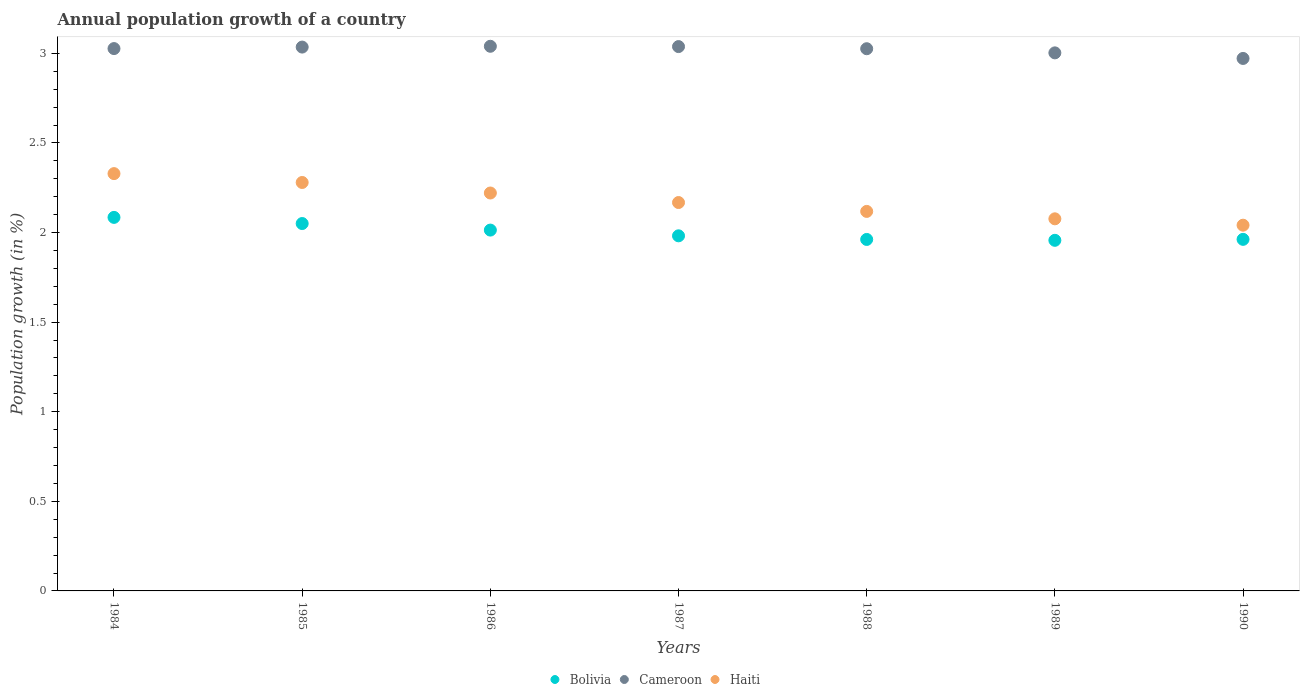How many different coloured dotlines are there?
Ensure brevity in your answer.  3. Is the number of dotlines equal to the number of legend labels?
Make the answer very short. Yes. What is the annual population growth in Bolivia in 1987?
Offer a terse response. 1.98. Across all years, what is the maximum annual population growth in Cameroon?
Keep it short and to the point. 3.04. Across all years, what is the minimum annual population growth in Bolivia?
Keep it short and to the point. 1.96. What is the total annual population growth in Haiti in the graph?
Provide a succinct answer. 15.23. What is the difference between the annual population growth in Bolivia in 1986 and that in 1989?
Make the answer very short. 0.06. What is the difference between the annual population growth in Cameroon in 1984 and the annual population growth in Bolivia in 1988?
Your answer should be compact. 1.07. What is the average annual population growth in Haiti per year?
Provide a short and direct response. 2.18. In the year 1989, what is the difference between the annual population growth in Haiti and annual population growth in Cameroon?
Provide a succinct answer. -0.93. In how many years, is the annual population growth in Cameroon greater than 2.3 %?
Provide a succinct answer. 7. What is the ratio of the annual population growth in Bolivia in 1985 to that in 1986?
Your response must be concise. 1.02. Is the annual population growth in Cameroon in 1984 less than that in 1987?
Make the answer very short. Yes. Is the difference between the annual population growth in Haiti in 1986 and 1988 greater than the difference between the annual population growth in Cameroon in 1986 and 1988?
Your answer should be very brief. Yes. What is the difference between the highest and the second highest annual population growth in Haiti?
Your response must be concise. 0.05. What is the difference between the highest and the lowest annual population growth in Cameroon?
Give a very brief answer. 0.07. Is it the case that in every year, the sum of the annual population growth in Bolivia and annual population growth in Haiti  is greater than the annual population growth in Cameroon?
Your answer should be compact. Yes. Does the annual population growth in Haiti monotonically increase over the years?
Ensure brevity in your answer.  No. Is the annual population growth in Cameroon strictly greater than the annual population growth in Bolivia over the years?
Keep it short and to the point. Yes. Is the annual population growth in Haiti strictly less than the annual population growth in Cameroon over the years?
Keep it short and to the point. Yes. How many dotlines are there?
Your answer should be compact. 3. How many years are there in the graph?
Your response must be concise. 7. What is the difference between two consecutive major ticks on the Y-axis?
Your answer should be compact. 0.5. Are the values on the major ticks of Y-axis written in scientific E-notation?
Keep it short and to the point. No. Does the graph contain grids?
Your response must be concise. No. Where does the legend appear in the graph?
Give a very brief answer. Bottom center. How many legend labels are there?
Offer a very short reply. 3. What is the title of the graph?
Ensure brevity in your answer.  Annual population growth of a country. Does "Gambia, The" appear as one of the legend labels in the graph?
Your answer should be very brief. No. What is the label or title of the X-axis?
Your answer should be compact. Years. What is the label or title of the Y-axis?
Keep it short and to the point. Population growth (in %). What is the Population growth (in %) of Bolivia in 1984?
Give a very brief answer. 2.08. What is the Population growth (in %) in Cameroon in 1984?
Your answer should be very brief. 3.03. What is the Population growth (in %) in Haiti in 1984?
Offer a terse response. 2.33. What is the Population growth (in %) in Bolivia in 1985?
Keep it short and to the point. 2.05. What is the Population growth (in %) in Cameroon in 1985?
Your response must be concise. 3.03. What is the Population growth (in %) in Haiti in 1985?
Your answer should be very brief. 2.28. What is the Population growth (in %) of Bolivia in 1986?
Provide a short and direct response. 2.01. What is the Population growth (in %) of Cameroon in 1986?
Your response must be concise. 3.04. What is the Population growth (in %) of Haiti in 1986?
Offer a terse response. 2.22. What is the Population growth (in %) of Bolivia in 1987?
Your answer should be compact. 1.98. What is the Population growth (in %) of Cameroon in 1987?
Provide a succinct answer. 3.04. What is the Population growth (in %) of Haiti in 1987?
Make the answer very short. 2.17. What is the Population growth (in %) of Bolivia in 1988?
Your answer should be compact. 1.96. What is the Population growth (in %) of Cameroon in 1988?
Ensure brevity in your answer.  3.03. What is the Population growth (in %) of Haiti in 1988?
Provide a short and direct response. 2.12. What is the Population growth (in %) of Bolivia in 1989?
Provide a succinct answer. 1.96. What is the Population growth (in %) of Cameroon in 1989?
Offer a terse response. 3. What is the Population growth (in %) in Haiti in 1989?
Your answer should be very brief. 2.08. What is the Population growth (in %) in Bolivia in 1990?
Give a very brief answer. 1.96. What is the Population growth (in %) in Cameroon in 1990?
Give a very brief answer. 2.97. What is the Population growth (in %) in Haiti in 1990?
Your answer should be compact. 2.04. Across all years, what is the maximum Population growth (in %) in Bolivia?
Offer a very short reply. 2.08. Across all years, what is the maximum Population growth (in %) in Cameroon?
Keep it short and to the point. 3.04. Across all years, what is the maximum Population growth (in %) of Haiti?
Make the answer very short. 2.33. Across all years, what is the minimum Population growth (in %) of Bolivia?
Offer a terse response. 1.96. Across all years, what is the minimum Population growth (in %) in Cameroon?
Ensure brevity in your answer.  2.97. Across all years, what is the minimum Population growth (in %) in Haiti?
Your response must be concise. 2.04. What is the total Population growth (in %) of Bolivia in the graph?
Offer a terse response. 14.01. What is the total Population growth (in %) in Cameroon in the graph?
Your answer should be compact. 21.14. What is the total Population growth (in %) of Haiti in the graph?
Offer a very short reply. 15.23. What is the difference between the Population growth (in %) in Bolivia in 1984 and that in 1985?
Your response must be concise. 0.03. What is the difference between the Population growth (in %) of Cameroon in 1984 and that in 1985?
Keep it short and to the point. -0.01. What is the difference between the Population growth (in %) in Haiti in 1984 and that in 1985?
Your answer should be very brief. 0.05. What is the difference between the Population growth (in %) in Bolivia in 1984 and that in 1986?
Your answer should be very brief. 0.07. What is the difference between the Population growth (in %) in Cameroon in 1984 and that in 1986?
Provide a succinct answer. -0.01. What is the difference between the Population growth (in %) of Haiti in 1984 and that in 1986?
Your response must be concise. 0.11. What is the difference between the Population growth (in %) in Bolivia in 1984 and that in 1987?
Your answer should be compact. 0.1. What is the difference between the Population growth (in %) in Cameroon in 1984 and that in 1987?
Give a very brief answer. -0.01. What is the difference between the Population growth (in %) of Haiti in 1984 and that in 1987?
Give a very brief answer. 0.16. What is the difference between the Population growth (in %) in Bolivia in 1984 and that in 1988?
Your response must be concise. 0.12. What is the difference between the Population growth (in %) in Cameroon in 1984 and that in 1988?
Keep it short and to the point. 0. What is the difference between the Population growth (in %) of Haiti in 1984 and that in 1988?
Offer a terse response. 0.21. What is the difference between the Population growth (in %) in Bolivia in 1984 and that in 1989?
Provide a succinct answer. 0.13. What is the difference between the Population growth (in %) in Cameroon in 1984 and that in 1989?
Keep it short and to the point. 0.02. What is the difference between the Population growth (in %) of Haiti in 1984 and that in 1989?
Offer a terse response. 0.25. What is the difference between the Population growth (in %) in Bolivia in 1984 and that in 1990?
Provide a succinct answer. 0.12. What is the difference between the Population growth (in %) of Cameroon in 1984 and that in 1990?
Provide a short and direct response. 0.06. What is the difference between the Population growth (in %) in Haiti in 1984 and that in 1990?
Give a very brief answer. 0.29. What is the difference between the Population growth (in %) in Bolivia in 1985 and that in 1986?
Offer a terse response. 0.04. What is the difference between the Population growth (in %) in Cameroon in 1985 and that in 1986?
Your answer should be compact. -0. What is the difference between the Population growth (in %) of Haiti in 1985 and that in 1986?
Your answer should be compact. 0.06. What is the difference between the Population growth (in %) of Bolivia in 1985 and that in 1987?
Keep it short and to the point. 0.07. What is the difference between the Population growth (in %) in Cameroon in 1985 and that in 1987?
Your answer should be very brief. -0. What is the difference between the Population growth (in %) in Haiti in 1985 and that in 1987?
Your response must be concise. 0.11. What is the difference between the Population growth (in %) of Bolivia in 1985 and that in 1988?
Ensure brevity in your answer.  0.09. What is the difference between the Population growth (in %) of Cameroon in 1985 and that in 1988?
Provide a short and direct response. 0.01. What is the difference between the Population growth (in %) in Haiti in 1985 and that in 1988?
Your answer should be compact. 0.16. What is the difference between the Population growth (in %) of Bolivia in 1985 and that in 1989?
Your answer should be compact. 0.09. What is the difference between the Population growth (in %) of Cameroon in 1985 and that in 1989?
Your answer should be very brief. 0.03. What is the difference between the Population growth (in %) in Haiti in 1985 and that in 1989?
Provide a short and direct response. 0.2. What is the difference between the Population growth (in %) in Bolivia in 1985 and that in 1990?
Provide a succinct answer. 0.09. What is the difference between the Population growth (in %) of Cameroon in 1985 and that in 1990?
Ensure brevity in your answer.  0.06. What is the difference between the Population growth (in %) of Haiti in 1985 and that in 1990?
Provide a succinct answer. 0.24. What is the difference between the Population growth (in %) of Bolivia in 1986 and that in 1987?
Your response must be concise. 0.03. What is the difference between the Population growth (in %) of Cameroon in 1986 and that in 1987?
Provide a succinct answer. 0. What is the difference between the Population growth (in %) in Haiti in 1986 and that in 1987?
Keep it short and to the point. 0.05. What is the difference between the Population growth (in %) in Bolivia in 1986 and that in 1988?
Keep it short and to the point. 0.05. What is the difference between the Population growth (in %) of Cameroon in 1986 and that in 1988?
Provide a short and direct response. 0.01. What is the difference between the Population growth (in %) in Haiti in 1986 and that in 1988?
Make the answer very short. 0.1. What is the difference between the Population growth (in %) in Bolivia in 1986 and that in 1989?
Offer a very short reply. 0.06. What is the difference between the Population growth (in %) of Cameroon in 1986 and that in 1989?
Give a very brief answer. 0.04. What is the difference between the Population growth (in %) of Haiti in 1986 and that in 1989?
Offer a very short reply. 0.14. What is the difference between the Population growth (in %) of Bolivia in 1986 and that in 1990?
Provide a short and direct response. 0.05. What is the difference between the Population growth (in %) of Cameroon in 1986 and that in 1990?
Keep it short and to the point. 0.07. What is the difference between the Population growth (in %) in Haiti in 1986 and that in 1990?
Make the answer very short. 0.18. What is the difference between the Population growth (in %) in Bolivia in 1987 and that in 1988?
Make the answer very short. 0.02. What is the difference between the Population growth (in %) in Cameroon in 1987 and that in 1988?
Your response must be concise. 0.01. What is the difference between the Population growth (in %) in Haiti in 1987 and that in 1988?
Give a very brief answer. 0.05. What is the difference between the Population growth (in %) of Bolivia in 1987 and that in 1989?
Your answer should be compact. 0.03. What is the difference between the Population growth (in %) of Cameroon in 1987 and that in 1989?
Keep it short and to the point. 0.04. What is the difference between the Population growth (in %) of Haiti in 1987 and that in 1989?
Your response must be concise. 0.09. What is the difference between the Population growth (in %) in Bolivia in 1987 and that in 1990?
Offer a very short reply. 0.02. What is the difference between the Population growth (in %) in Cameroon in 1987 and that in 1990?
Make the answer very short. 0.07. What is the difference between the Population growth (in %) of Haiti in 1987 and that in 1990?
Provide a succinct answer. 0.13. What is the difference between the Population growth (in %) in Bolivia in 1988 and that in 1989?
Your response must be concise. 0. What is the difference between the Population growth (in %) of Cameroon in 1988 and that in 1989?
Provide a succinct answer. 0.02. What is the difference between the Population growth (in %) in Haiti in 1988 and that in 1989?
Make the answer very short. 0.04. What is the difference between the Population growth (in %) in Bolivia in 1988 and that in 1990?
Provide a short and direct response. -0. What is the difference between the Population growth (in %) in Cameroon in 1988 and that in 1990?
Keep it short and to the point. 0.05. What is the difference between the Population growth (in %) in Haiti in 1988 and that in 1990?
Your response must be concise. 0.08. What is the difference between the Population growth (in %) in Bolivia in 1989 and that in 1990?
Provide a short and direct response. -0.01. What is the difference between the Population growth (in %) in Cameroon in 1989 and that in 1990?
Make the answer very short. 0.03. What is the difference between the Population growth (in %) of Haiti in 1989 and that in 1990?
Ensure brevity in your answer.  0.04. What is the difference between the Population growth (in %) in Bolivia in 1984 and the Population growth (in %) in Cameroon in 1985?
Offer a terse response. -0.95. What is the difference between the Population growth (in %) in Bolivia in 1984 and the Population growth (in %) in Haiti in 1985?
Offer a very short reply. -0.19. What is the difference between the Population growth (in %) of Cameroon in 1984 and the Population growth (in %) of Haiti in 1985?
Provide a succinct answer. 0.75. What is the difference between the Population growth (in %) in Bolivia in 1984 and the Population growth (in %) in Cameroon in 1986?
Give a very brief answer. -0.95. What is the difference between the Population growth (in %) in Bolivia in 1984 and the Population growth (in %) in Haiti in 1986?
Make the answer very short. -0.14. What is the difference between the Population growth (in %) of Cameroon in 1984 and the Population growth (in %) of Haiti in 1986?
Offer a very short reply. 0.81. What is the difference between the Population growth (in %) in Bolivia in 1984 and the Population growth (in %) in Cameroon in 1987?
Make the answer very short. -0.95. What is the difference between the Population growth (in %) of Bolivia in 1984 and the Population growth (in %) of Haiti in 1987?
Your answer should be very brief. -0.08. What is the difference between the Population growth (in %) in Cameroon in 1984 and the Population growth (in %) in Haiti in 1987?
Keep it short and to the point. 0.86. What is the difference between the Population growth (in %) in Bolivia in 1984 and the Population growth (in %) in Cameroon in 1988?
Offer a terse response. -0.94. What is the difference between the Population growth (in %) of Bolivia in 1984 and the Population growth (in %) of Haiti in 1988?
Offer a very short reply. -0.03. What is the difference between the Population growth (in %) of Cameroon in 1984 and the Population growth (in %) of Haiti in 1988?
Offer a terse response. 0.91. What is the difference between the Population growth (in %) of Bolivia in 1984 and the Population growth (in %) of Cameroon in 1989?
Your answer should be compact. -0.92. What is the difference between the Population growth (in %) of Bolivia in 1984 and the Population growth (in %) of Haiti in 1989?
Offer a very short reply. 0.01. What is the difference between the Population growth (in %) in Cameroon in 1984 and the Population growth (in %) in Haiti in 1989?
Your answer should be very brief. 0.95. What is the difference between the Population growth (in %) in Bolivia in 1984 and the Population growth (in %) in Cameroon in 1990?
Offer a very short reply. -0.89. What is the difference between the Population growth (in %) of Bolivia in 1984 and the Population growth (in %) of Haiti in 1990?
Offer a very short reply. 0.04. What is the difference between the Population growth (in %) of Cameroon in 1984 and the Population growth (in %) of Haiti in 1990?
Ensure brevity in your answer.  0.99. What is the difference between the Population growth (in %) in Bolivia in 1985 and the Population growth (in %) in Cameroon in 1986?
Give a very brief answer. -0.99. What is the difference between the Population growth (in %) in Bolivia in 1985 and the Population growth (in %) in Haiti in 1986?
Ensure brevity in your answer.  -0.17. What is the difference between the Population growth (in %) in Cameroon in 1985 and the Population growth (in %) in Haiti in 1986?
Provide a short and direct response. 0.81. What is the difference between the Population growth (in %) in Bolivia in 1985 and the Population growth (in %) in Cameroon in 1987?
Offer a terse response. -0.99. What is the difference between the Population growth (in %) in Bolivia in 1985 and the Population growth (in %) in Haiti in 1987?
Offer a terse response. -0.12. What is the difference between the Population growth (in %) in Cameroon in 1985 and the Population growth (in %) in Haiti in 1987?
Provide a succinct answer. 0.87. What is the difference between the Population growth (in %) of Bolivia in 1985 and the Population growth (in %) of Cameroon in 1988?
Offer a very short reply. -0.98. What is the difference between the Population growth (in %) of Bolivia in 1985 and the Population growth (in %) of Haiti in 1988?
Provide a succinct answer. -0.07. What is the difference between the Population growth (in %) in Cameroon in 1985 and the Population growth (in %) in Haiti in 1988?
Ensure brevity in your answer.  0.92. What is the difference between the Population growth (in %) of Bolivia in 1985 and the Population growth (in %) of Cameroon in 1989?
Your response must be concise. -0.95. What is the difference between the Population growth (in %) of Bolivia in 1985 and the Population growth (in %) of Haiti in 1989?
Your answer should be compact. -0.03. What is the difference between the Population growth (in %) in Cameroon in 1985 and the Population growth (in %) in Haiti in 1989?
Offer a terse response. 0.96. What is the difference between the Population growth (in %) of Bolivia in 1985 and the Population growth (in %) of Cameroon in 1990?
Make the answer very short. -0.92. What is the difference between the Population growth (in %) of Bolivia in 1985 and the Population growth (in %) of Haiti in 1990?
Ensure brevity in your answer.  0.01. What is the difference between the Population growth (in %) of Cameroon in 1985 and the Population growth (in %) of Haiti in 1990?
Provide a short and direct response. 0.99. What is the difference between the Population growth (in %) of Bolivia in 1986 and the Population growth (in %) of Cameroon in 1987?
Provide a succinct answer. -1.02. What is the difference between the Population growth (in %) of Bolivia in 1986 and the Population growth (in %) of Haiti in 1987?
Keep it short and to the point. -0.15. What is the difference between the Population growth (in %) of Cameroon in 1986 and the Population growth (in %) of Haiti in 1987?
Your response must be concise. 0.87. What is the difference between the Population growth (in %) in Bolivia in 1986 and the Population growth (in %) in Cameroon in 1988?
Ensure brevity in your answer.  -1.01. What is the difference between the Population growth (in %) of Bolivia in 1986 and the Population growth (in %) of Haiti in 1988?
Provide a succinct answer. -0.1. What is the difference between the Population growth (in %) in Cameroon in 1986 and the Population growth (in %) in Haiti in 1988?
Offer a very short reply. 0.92. What is the difference between the Population growth (in %) in Bolivia in 1986 and the Population growth (in %) in Cameroon in 1989?
Your response must be concise. -0.99. What is the difference between the Population growth (in %) in Bolivia in 1986 and the Population growth (in %) in Haiti in 1989?
Offer a very short reply. -0.06. What is the difference between the Population growth (in %) in Cameroon in 1986 and the Population growth (in %) in Haiti in 1989?
Provide a succinct answer. 0.96. What is the difference between the Population growth (in %) of Bolivia in 1986 and the Population growth (in %) of Cameroon in 1990?
Your response must be concise. -0.96. What is the difference between the Population growth (in %) in Bolivia in 1986 and the Population growth (in %) in Haiti in 1990?
Keep it short and to the point. -0.03. What is the difference between the Population growth (in %) of Bolivia in 1987 and the Population growth (in %) of Cameroon in 1988?
Provide a short and direct response. -1.04. What is the difference between the Population growth (in %) of Bolivia in 1987 and the Population growth (in %) of Haiti in 1988?
Your answer should be compact. -0.14. What is the difference between the Population growth (in %) of Cameroon in 1987 and the Population growth (in %) of Haiti in 1988?
Your response must be concise. 0.92. What is the difference between the Population growth (in %) in Bolivia in 1987 and the Population growth (in %) in Cameroon in 1989?
Provide a succinct answer. -1.02. What is the difference between the Population growth (in %) in Bolivia in 1987 and the Population growth (in %) in Haiti in 1989?
Offer a terse response. -0.09. What is the difference between the Population growth (in %) of Cameroon in 1987 and the Population growth (in %) of Haiti in 1989?
Keep it short and to the point. 0.96. What is the difference between the Population growth (in %) in Bolivia in 1987 and the Population growth (in %) in Cameroon in 1990?
Offer a terse response. -0.99. What is the difference between the Population growth (in %) of Bolivia in 1987 and the Population growth (in %) of Haiti in 1990?
Your answer should be very brief. -0.06. What is the difference between the Population growth (in %) of Cameroon in 1987 and the Population growth (in %) of Haiti in 1990?
Give a very brief answer. 1. What is the difference between the Population growth (in %) of Bolivia in 1988 and the Population growth (in %) of Cameroon in 1989?
Provide a short and direct response. -1.04. What is the difference between the Population growth (in %) in Bolivia in 1988 and the Population growth (in %) in Haiti in 1989?
Keep it short and to the point. -0.12. What is the difference between the Population growth (in %) in Cameroon in 1988 and the Population growth (in %) in Haiti in 1989?
Ensure brevity in your answer.  0.95. What is the difference between the Population growth (in %) in Bolivia in 1988 and the Population growth (in %) in Cameroon in 1990?
Offer a very short reply. -1.01. What is the difference between the Population growth (in %) in Bolivia in 1988 and the Population growth (in %) in Haiti in 1990?
Provide a short and direct response. -0.08. What is the difference between the Population growth (in %) in Cameroon in 1988 and the Population growth (in %) in Haiti in 1990?
Provide a short and direct response. 0.98. What is the difference between the Population growth (in %) in Bolivia in 1989 and the Population growth (in %) in Cameroon in 1990?
Give a very brief answer. -1.01. What is the difference between the Population growth (in %) of Bolivia in 1989 and the Population growth (in %) of Haiti in 1990?
Your answer should be compact. -0.08. What is the difference between the Population growth (in %) of Cameroon in 1989 and the Population growth (in %) of Haiti in 1990?
Provide a short and direct response. 0.96. What is the average Population growth (in %) in Bolivia per year?
Keep it short and to the point. 2. What is the average Population growth (in %) in Cameroon per year?
Provide a succinct answer. 3.02. What is the average Population growth (in %) of Haiti per year?
Make the answer very short. 2.18. In the year 1984, what is the difference between the Population growth (in %) in Bolivia and Population growth (in %) in Cameroon?
Give a very brief answer. -0.94. In the year 1984, what is the difference between the Population growth (in %) of Bolivia and Population growth (in %) of Haiti?
Offer a terse response. -0.24. In the year 1984, what is the difference between the Population growth (in %) of Cameroon and Population growth (in %) of Haiti?
Make the answer very short. 0.7. In the year 1985, what is the difference between the Population growth (in %) in Bolivia and Population growth (in %) in Cameroon?
Your answer should be compact. -0.98. In the year 1985, what is the difference between the Population growth (in %) of Bolivia and Population growth (in %) of Haiti?
Give a very brief answer. -0.23. In the year 1985, what is the difference between the Population growth (in %) of Cameroon and Population growth (in %) of Haiti?
Provide a short and direct response. 0.76. In the year 1986, what is the difference between the Population growth (in %) of Bolivia and Population growth (in %) of Cameroon?
Your answer should be compact. -1.03. In the year 1986, what is the difference between the Population growth (in %) of Bolivia and Population growth (in %) of Haiti?
Your answer should be very brief. -0.21. In the year 1986, what is the difference between the Population growth (in %) of Cameroon and Population growth (in %) of Haiti?
Give a very brief answer. 0.82. In the year 1987, what is the difference between the Population growth (in %) of Bolivia and Population growth (in %) of Cameroon?
Provide a succinct answer. -1.06. In the year 1987, what is the difference between the Population growth (in %) of Bolivia and Population growth (in %) of Haiti?
Give a very brief answer. -0.19. In the year 1987, what is the difference between the Population growth (in %) of Cameroon and Population growth (in %) of Haiti?
Your answer should be very brief. 0.87. In the year 1988, what is the difference between the Population growth (in %) in Bolivia and Population growth (in %) in Cameroon?
Keep it short and to the point. -1.06. In the year 1988, what is the difference between the Population growth (in %) in Bolivia and Population growth (in %) in Haiti?
Offer a very short reply. -0.16. In the year 1988, what is the difference between the Population growth (in %) in Cameroon and Population growth (in %) in Haiti?
Give a very brief answer. 0.91. In the year 1989, what is the difference between the Population growth (in %) of Bolivia and Population growth (in %) of Cameroon?
Your answer should be very brief. -1.05. In the year 1989, what is the difference between the Population growth (in %) in Bolivia and Population growth (in %) in Haiti?
Give a very brief answer. -0.12. In the year 1989, what is the difference between the Population growth (in %) of Cameroon and Population growth (in %) of Haiti?
Ensure brevity in your answer.  0.93. In the year 1990, what is the difference between the Population growth (in %) in Bolivia and Population growth (in %) in Cameroon?
Your answer should be compact. -1.01. In the year 1990, what is the difference between the Population growth (in %) in Bolivia and Population growth (in %) in Haiti?
Offer a very short reply. -0.08. In the year 1990, what is the difference between the Population growth (in %) of Cameroon and Population growth (in %) of Haiti?
Your answer should be very brief. 0.93. What is the ratio of the Population growth (in %) of Bolivia in 1984 to that in 1985?
Offer a terse response. 1.02. What is the ratio of the Population growth (in %) in Haiti in 1984 to that in 1985?
Offer a terse response. 1.02. What is the ratio of the Population growth (in %) of Bolivia in 1984 to that in 1986?
Provide a succinct answer. 1.04. What is the ratio of the Population growth (in %) of Haiti in 1984 to that in 1986?
Your answer should be compact. 1.05. What is the ratio of the Population growth (in %) of Bolivia in 1984 to that in 1987?
Make the answer very short. 1.05. What is the ratio of the Population growth (in %) in Haiti in 1984 to that in 1987?
Ensure brevity in your answer.  1.07. What is the ratio of the Population growth (in %) in Bolivia in 1984 to that in 1988?
Your answer should be compact. 1.06. What is the ratio of the Population growth (in %) of Cameroon in 1984 to that in 1988?
Keep it short and to the point. 1. What is the ratio of the Population growth (in %) of Haiti in 1984 to that in 1988?
Give a very brief answer. 1.1. What is the ratio of the Population growth (in %) of Bolivia in 1984 to that in 1989?
Ensure brevity in your answer.  1.07. What is the ratio of the Population growth (in %) in Cameroon in 1984 to that in 1989?
Provide a succinct answer. 1.01. What is the ratio of the Population growth (in %) of Haiti in 1984 to that in 1989?
Your answer should be compact. 1.12. What is the ratio of the Population growth (in %) in Bolivia in 1984 to that in 1990?
Give a very brief answer. 1.06. What is the ratio of the Population growth (in %) in Cameroon in 1984 to that in 1990?
Provide a succinct answer. 1.02. What is the ratio of the Population growth (in %) in Haiti in 1984 to that in 1990?
Ensure brevity in your answer.  1.14. What is the ratio of the Population growth (in %) in Bolivia in 1985 to that in 1986?
Your response must be concise. 1.02. What is the ratio of the Population growth (in %) of Cameroon in 1985 to that in 1986?
Your response must be concise. 1. What is the ratio of the Population growth (in %) of Haiti in 1985 to that in 1986?
Provide a short and direct response. 1.03. What is the ratio of the Population growth (in %) in Bolivia in 1985 to that in 1987?
Make the answer very short. 1.03. What is the ratio of the Population growth (in %) of Haiti in 1985 to that in 1987?
Give a very brief answer. 1.05. What is the ratio of the Population growth (in %) of Bolivia in 1985 to that in 1988?
Your response must be concise. 1.05. What is the ratio of the Population growth (in %) of Cameroon in 1985 to that in 1988?
Ensure brevity in your answer.  1. What is the ratio of the Population growth (in %) in Haiti in 1985 to that in 1988?
Offer a terse response. 1.08. What is the ratio of the Population growth (in %) in Bolivia in 1985 to that in 1989?
Ensure brevity in your answer.  1.05. What is the ratio of the Population growth (in %) of Cameroon in 1985 to that in 1989?
Your answer should be very brief. 1.01. What is the ratio of the Population growth (in %) in Haiti in 1985 to that in 1989?
Ensure brevity in your answer.  1.1. What is the ratio of the Population growth (in %) of Bolivia in 1985 to that in 1990?
Your answer should be compact. 1.04. What is the ratio of the Population growth (in %) in Cameroon in 1985 to that in 1990?
Provide a succinct answer. 1.02. What is the ratio of the Population growth (in %) of Haiti in 1985 to that in 1990?
Provide a short and direct response. 1.12. What is the ratio of the Population growth (in %) in Bolivia in 1986 to that in 1987?
Your response must be concise. 1.02. What is the ratio of the Population growth (in %) of Cameroon in 1986 to that in 1987?
Keep it short and to the point. 1. What is the ratio of the Population growth (in %) in Haiti in 1986 to that in 1987?
Make the answer very short. 1.02. What is the ratio of the Population growth (in %) in Bolivia in 1986 to that in 1988?
Your response must be concise. 1.03. What is the ratio of the Population growth (in %) of Cameroon in 1986 to that in 1988?
Offer a terse response. 1. What is the ratio of the Population growth (in %) in Haiti in 1986 to that in 1988?
Your answer should be compact. 1.05. What is the ratio of the Population growth (in %) of Bolivia in 1986 to that in 1989?
Your answer should be very brief. 1.03. What is the ratio of the Population growth (in %) in Cameroon in 1986 to that in 1989?
Offer a terse response. 1.01. What is the ratio of the Population growth (in %) in Haiti in 1986 to that in 1989?
Offer a terse response. 1.07. What is the ratio of the Population growth (in %) of Bolivia in 1986 to that in 1990?
Give a very brief answer. 1.03. What is the ratio of the Population growth (in %) of Cameroon in 1986 to that in 1990?
Provide a short and direct response. 1.02. What is the ratio of the Population growth (in %) of Haiti in 1986 to that in 1990?
Provide a short and direct response. 1.09. What is the ratio of the Population growth (in %) in Bolivia in 1987 to that in 1988?
Offer a very short reply. 1.01. What is the ratio of the Population growth (in %) of Cameroon in 1987 to that in 1988?
Give a very brief answer. 1. What is the ratio of the Population growth (in %) in Haiti in 1987 to that in 1988?
Offer a terse response. 1.02. What is the ratio of the Population growth (in %) of Bolivia in 1987 to that in 1989?
Offer a very short reply. 1.01. What is the ratio of the Population growth (in %) of Cameroon in 1987 to that in 1989?
Offer a terse response. 1.01. What is the ratio of the Population growth (in %) in Haiti in 1987 to that in 1989?
Ensure brevity in your answer.  1.04. What is the ratio of the Population growth (in %) of Cameroon in 1987 to that in 1990?
Provide a succinct answer. 1.02. What is the ratio of the Population growth (in %) in Haiti in 1987 to that in 1990?
Offer a terse response. 1.06. What is the ratio of the Population growth (in %) in Bolivia in 1988 to that in 1989?
Your answer should be compact. 1. What is the ratio of the Population growth (in %) in Cameroon in 1988 to that in 1989?
Make the answer very short. 1.01. What is the ratio of the Population growth (in %) of Haiti in 1988 to that in 1989?
Offer a terse response. 1.02. What is the ratio of the Population growth (in %) in Bolivia in 1988 to that in 1990?
Make the answer very short. 1. What is the ratio of the Population growth (in %) of Cameroon in 1988 to that in 1990?
Your answer should be very brief. 1.02. What is the ratio of the Population growth (in %) of Haiti in 1988 to that in 1990?
Provide a short and direct response. 1.04. What is the ratio of the Population growth (in %) of Cameroon in 1989 to that in 1990?
Ensure brevity in your answer.  1.01. What is the ratio of the Population growth (in %) in Haiti in 1989 to that in 1990?
Provide a short and direct response. 1.02. What is the difference between the highest and the second highest Population growth (in %) in Bolivia?
Your answer should be compact. 0.03. What is the difference between the highest and the second highest Population growth (in %) in Cameroon?
Provide a succinct answer. 0. What is the difference between the highest and the second highest Population growth (in %) in Haiti?
Keep it short and to the point. 0.05. What is the difference between the highest and the lowest Population growth (in %) in Bolivia?
Your answer should be compact. 0.13. What is the difference between the highest and the lowest Population growth (in %) of Cameroon?
Make the answer very short. 0.07. What is the difference between the highest and the lowest Population growth (in %) in Haiti?
Your answer should be compact. 0.29. 